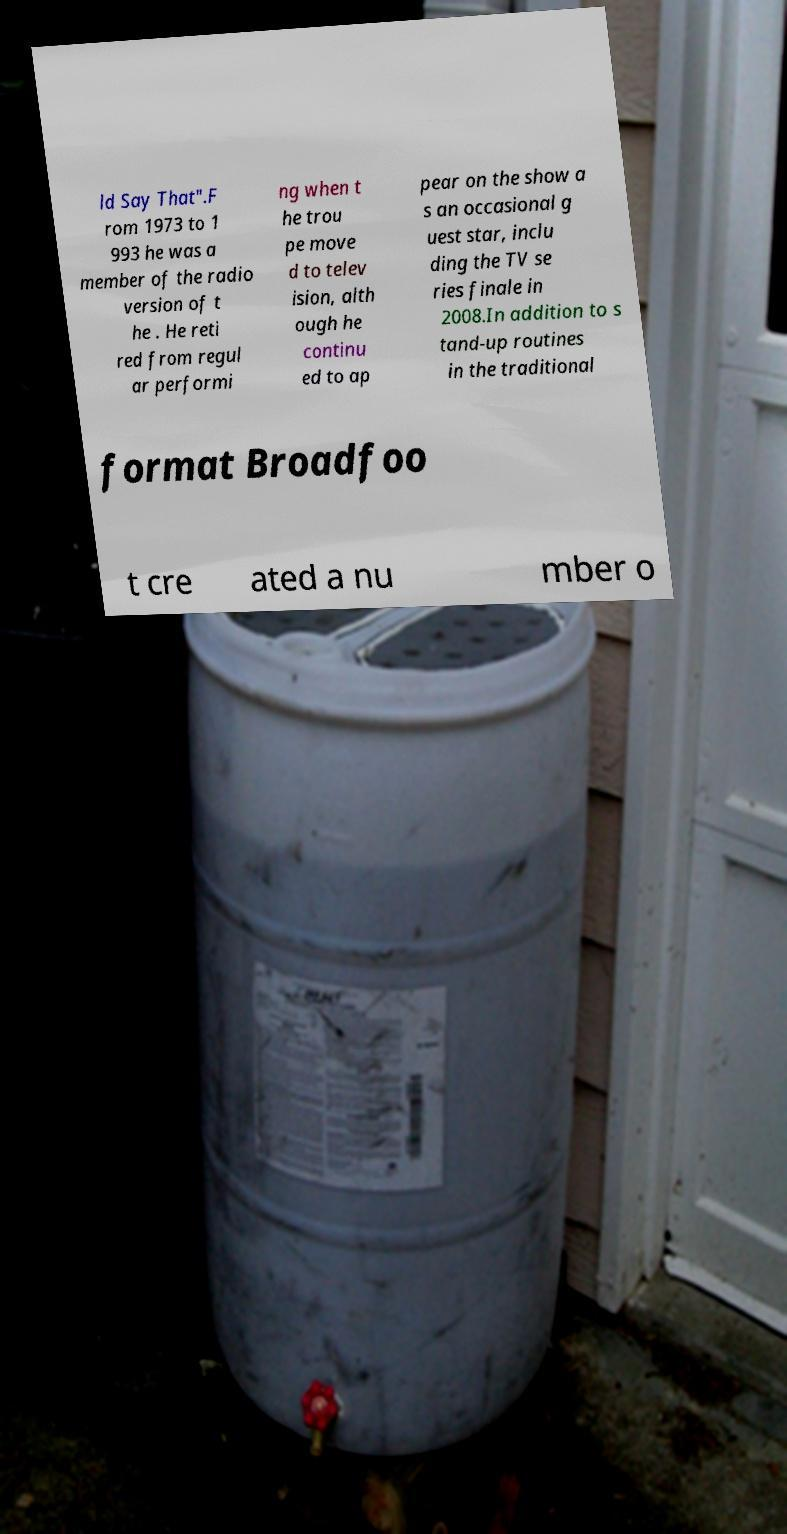Please identify and transcribe the text found in this image. ld Say That".F rom 1973 to 1 993 he was a member of the radio version of t he . He reti red from regul ar performi ng when t he trou pe move d to telev ision, alth ough he continu ed to ap pear on the show a s an occasional g uest star, inclu ding the TV se ries finale in 2008.In addition to s tand-up routines in the traditional format Broadfoo t cre ated a nu mber o 